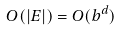<formula> <loc_0><loc_0><loc_500><loc_500>O ( | E | ) = O ( b ^ { d } )</formula> 